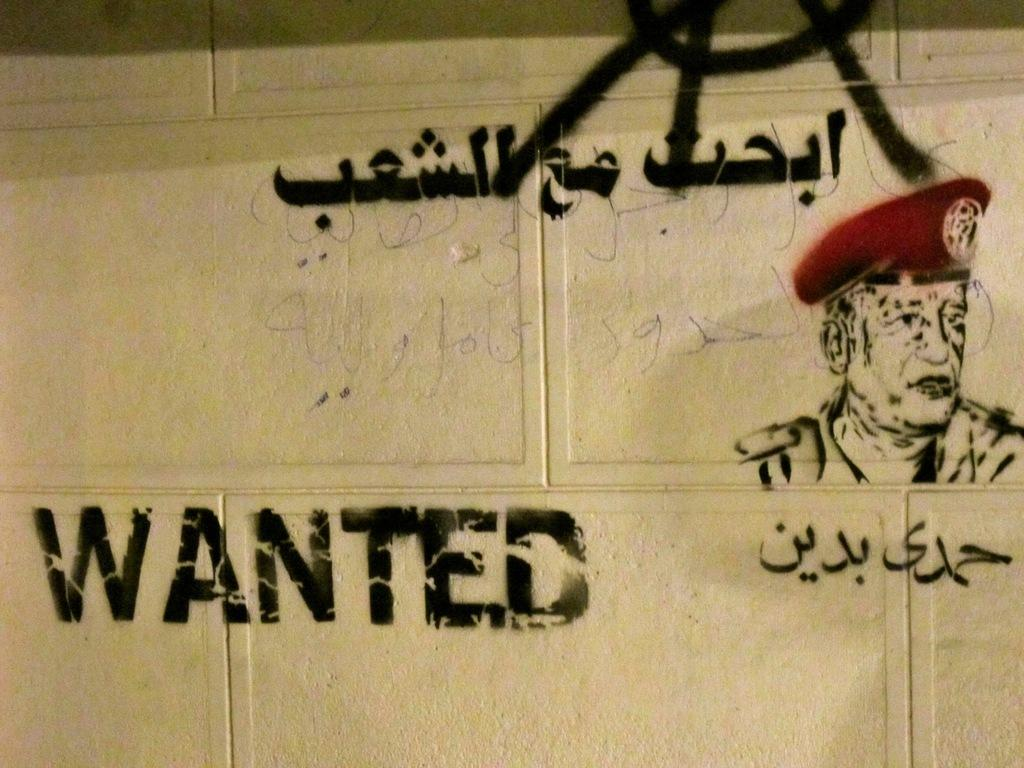What is located in the center of the image? There is a wall in the center of the image. What is depicted on the wall in the image? The wall has graffiti painting on it. What type of glue is being used to attach the father to the value in the image? There is no father or value present in the image, and therefore no glue or attachment process can be observed. 